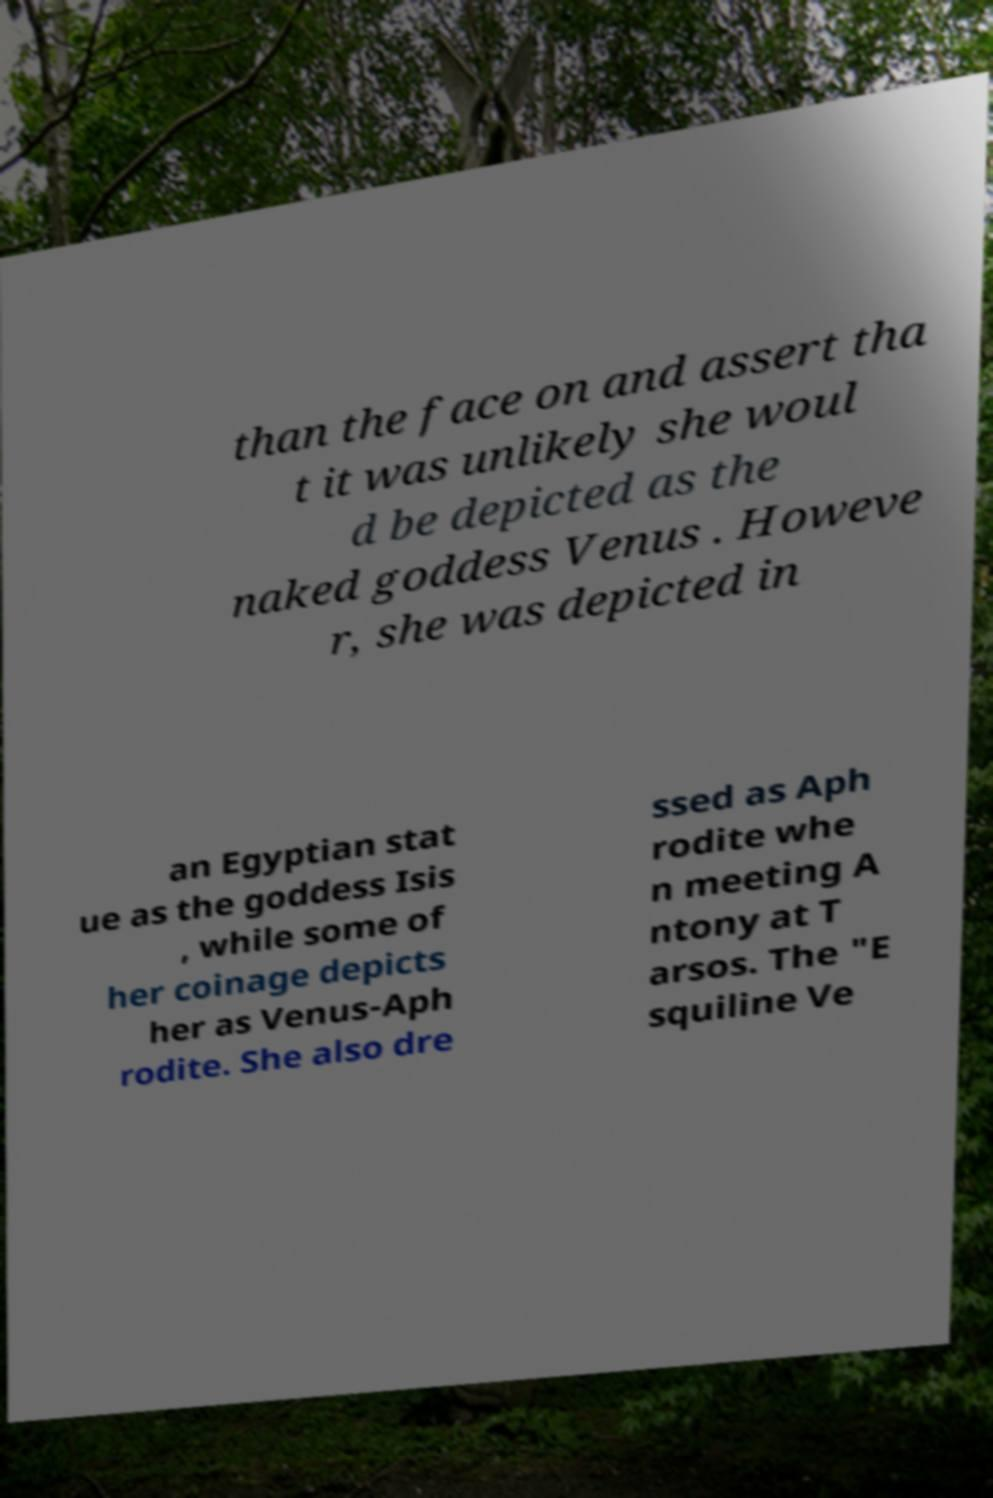Could you extract and type out the text from this image? than the face on and assert tha t it was unlikely she woul d be depicted as the naked goddess Venus . Howeve r, she was depicted in an Egyptian stat ue as the goddess Isis , while some of her coinage depicts her as Venus-Aph rodite. She also dre ssed as Aph rodite whe n meeting A ntony at T arsos. The "E squiline Ve 